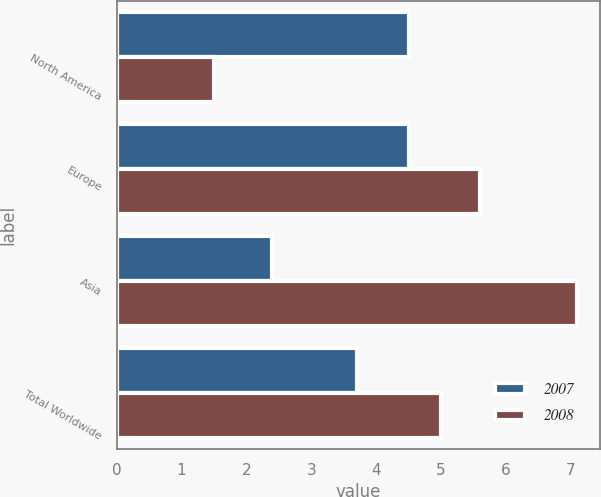Convert chart. <chart><loc_0><loc_0><loc_500><loc_500><stacked_bar_chart><ecel><fcel>North America<fcel>Europe<fcel>Asia<fcel>Total Worldwide<nl><fcel>2007<fcel>4.5<fcel>4.5<fcel>2.4<fcel>3.7<nl><fcel>2008<fcel>1.5<fcel>5.6<fcel>7.1<fcel>5<nl></chart> 